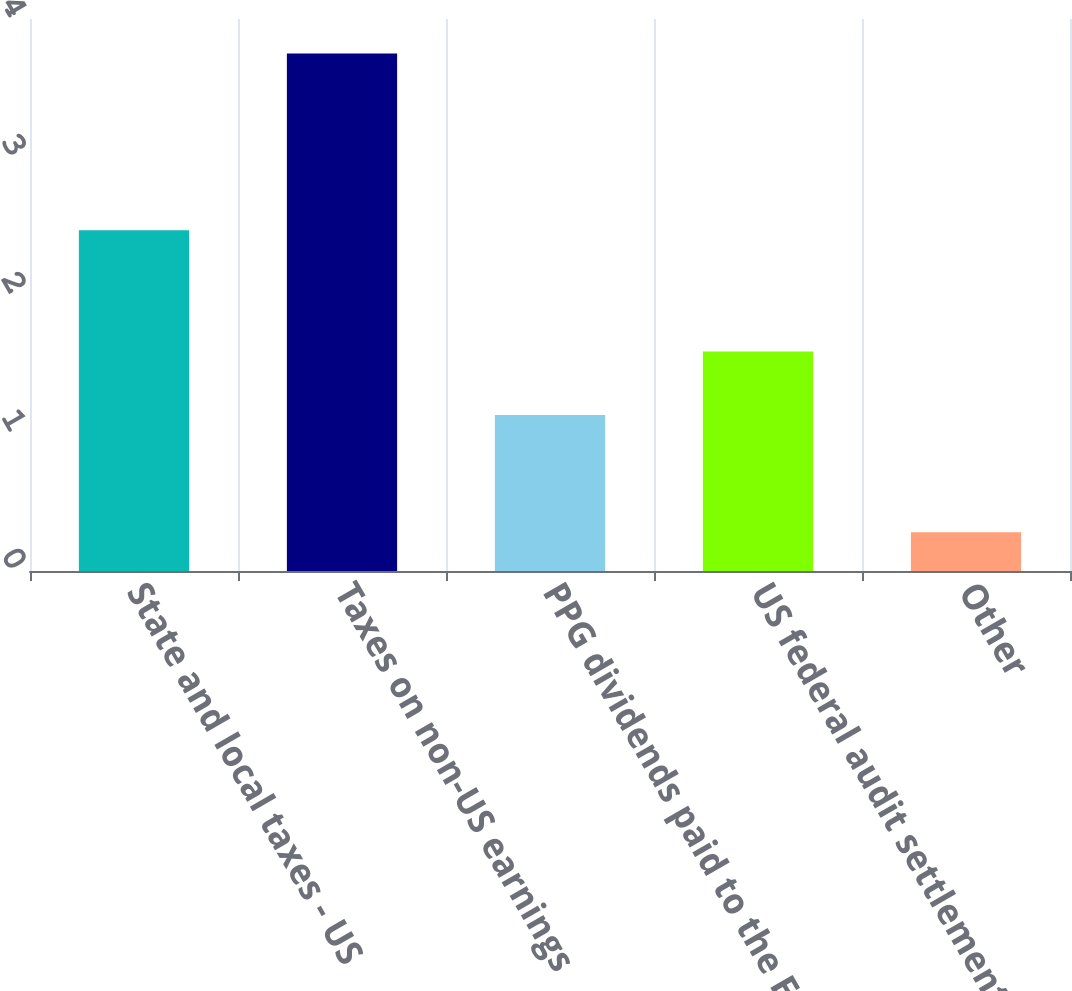<chart> <loc_0><loc_0><loc_500><loc_500><bar_chart><fcel>State and local taxes - US<fcel>Taxes on non-US earnings<fcel>PPG dividends paid to the ESOP<fcel>US federal audit settlements<fcel>Other<nl><fcel>2.47<fcel>3.75<fcel>1.13<fcel>1.59<fcel>0.28<nl></chart> 